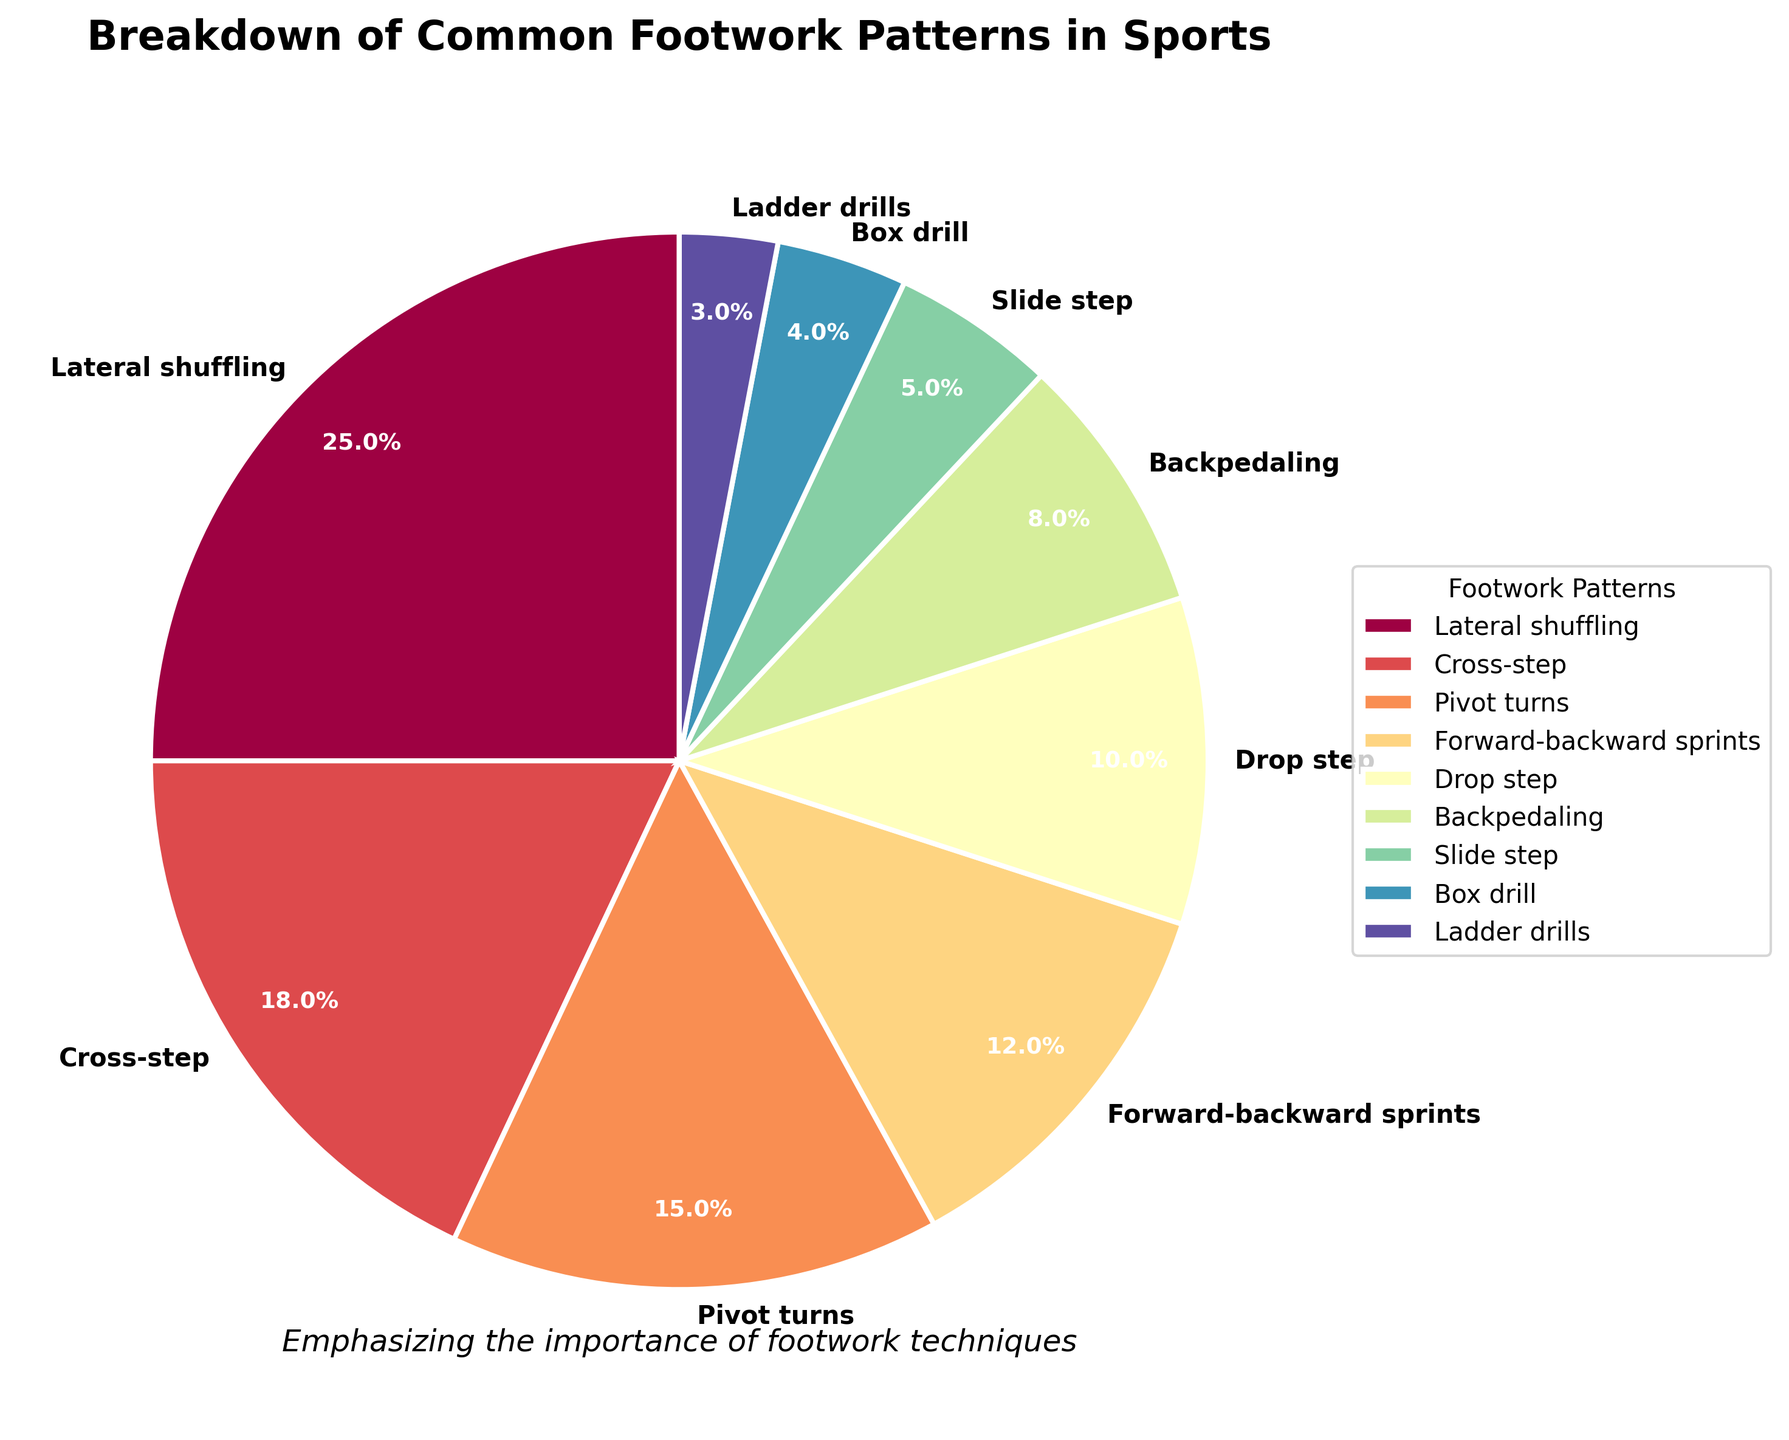What's the most common footwork pattern used? The pie chart clearly shows the segments sized by percentage. The largest segment represents Lateral shuffling with 25%.
Answer: Lateral shuffling Which footwork pattern is used the least often? By examining the smallest segment of the pie chart, Ladder drills are depicted with a 3% share, making it the least common.
Answer: Ladder drills How much more is Lateral shuffling used compared to Drop step? Lateral shuffling has 25% and Drop step has 10%, the difference can be calculated as 25 - 10 = 15%.
Answer: 15% Is there a larger percentage of usage in Forward-backward sprints or Pivot turns? According to the chart, Forward-backward sprints have 12% while Pivot turns have 15%, meaning Pivot turns have a higher percentage.
Answer: Pivot turns What is the combined percentage of Cross-step and Backpedaling? Cross-step is 18% and Backpedaling is 8%. Adding these together, 18 + 8 = 26%.
Answer: 26% Are Slide step and Box drill collectively used more than Drop step? Slide step accounts for 5% and Box drill for 4%, totaling 5 + 4 = 9%. Drop step itself is 10%, which means Drop step is used slightly more.
Answer: No Which patterns together make up over half of the total usage? The patterns and percentages are as follows: Lateral shuffling (25%), Cross-step (18%), Pivot turns (15%), Forward-backward sprints (12%). Adding Lateral shuffling and Cross-step, we get 25 + 18 = 43%. Adding Pivot turns, 43 + 15 = 58%, which is over half.
Answer: Lateral shuffling, Cross-step, Pivot turns How many footwork patterns constitute less than 10% each? Counting the patterns below 10%: Drop step (10%), Backpedaling (8%), Slide step (5%), Box drill (4%), Ladder drills (3%), we find that 5 patterns fit this criteria.
Answer: 5 Of the patterns with percentages shown, which has a relatively central segment color? Referring to the color spectrum used, spectrums in the middle range would be more central. Cross-step colored in the middle range of Spectral colormap seems central.
Answer: Cross-step What fraction do Pivot turns and Forward-backward sprints represent together? Pivot turns are 15% and Forward-backward sprints are 12%. Adding them together, 15 + 12 = 27%. Thus, they represent 27/100 or 27%.
Answer: 27% 